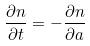Convert formula to latex. <formula><loc_0><loc_0><loc_500><loc_500>\frac { \partial n } { \partial t } = - \frac { \partial n } { \partial a }</formula> 